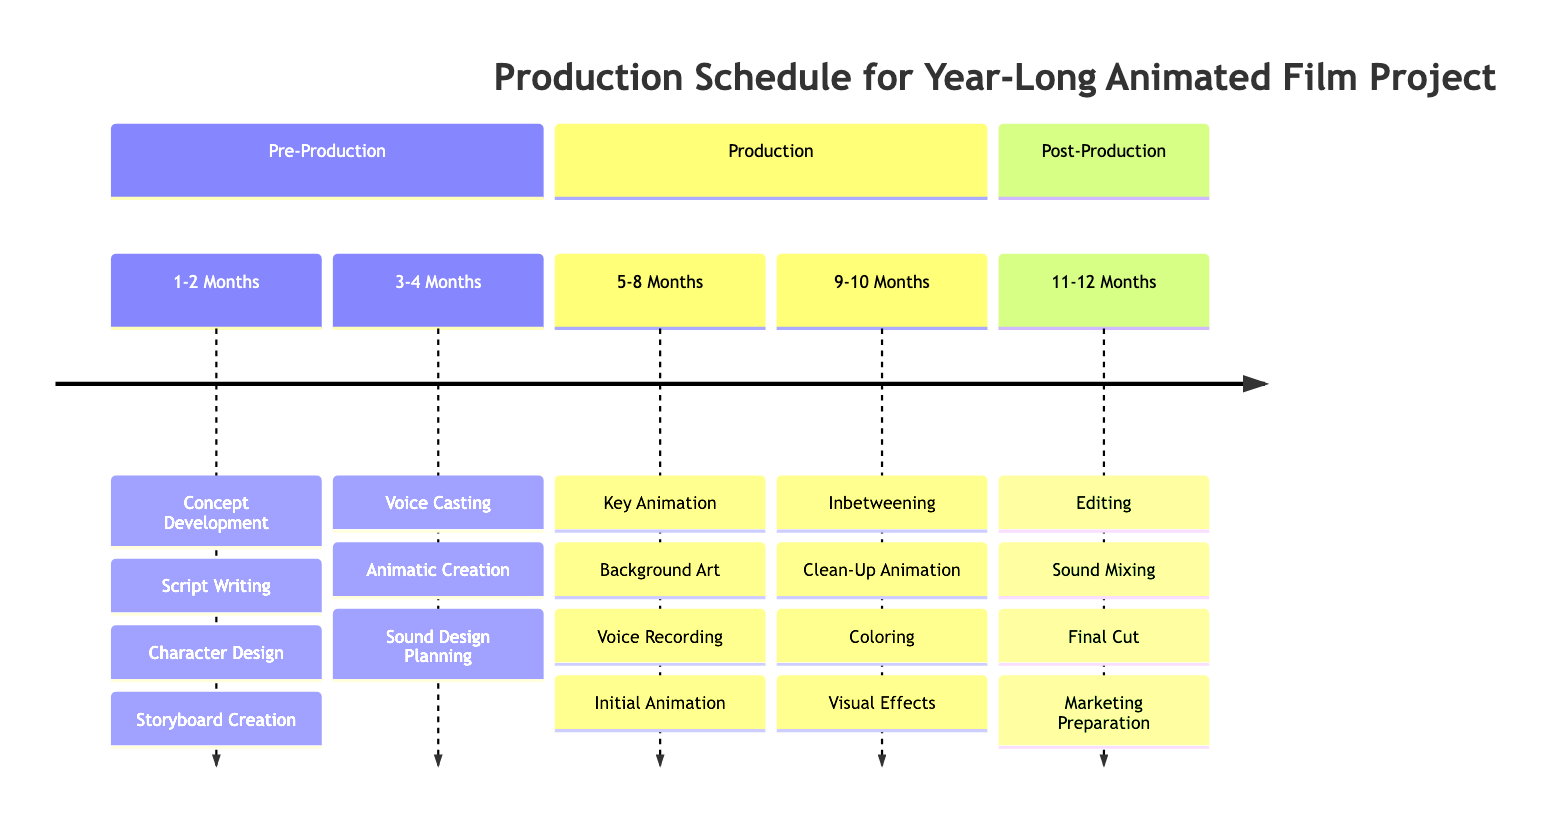What are the main phases of the production schedule? The diagram provides three primary phases: Pre-Production, Production, and Post-Production. Each phase is clearly defined in separate sections of the timeline.
Answer: Pre-Production, Production, Post-Production How long is the Pre-Production phase? The Pre-Production phase is divided into two segments: 1-2 months and 3-4 months, adding up to a total of 4 months for the entire phase.
Answer: 4 months What activities are involved in the Production phase from months 5 to 10? For months 5 to 8, the activities are Key Animation, Background Art, Voice Recording, and Initial Animation. For months 9 to 10, the activities are Inbetweening, Clean-Up Animation, Coloring, and Visual Effects. This requires looking at both segments of the Production phase.
Answer: Key Animation, Background Art, Voice Recording, Initial Animation, Inbetweening, Clean-Up Animation, Coloring, Visual Effects Which task comes immediately after Storyboard Creation? The task that follows Storyboard Creation is Voice Casting, as they are listed sequentially in the timeline.
Answer: Voice Casting How many tasks are listed under Post-Production? There are four tasks under Post-Production: Editing, Sound Mixing, Final Cut, and Marketing Preparation. This is obtained by counting the listed tasks in the Post-Production section of the timeline.
Answer: 4 tasks What is the last task in the entire production schedule? The last task listed is Marketing Preparation, which is the final task under Post-Production at the end of the timeline.
Answer: Marketing Preparation In which month does voice recording take place? Voice Recording is scheduled during the 5 to 8 months segment of the Production phase, specifically within that time frame.
Answer: 5 to 8 months What is the function of Animatic Creation in the timeline? Animatic Creation is a part of the Voice Casting and Sound Design Planning tasks in the 3-4 months segment of Pre-Production, indicating its role in preparing visual interactions for sound and narration.
Answer: Preparation for animation How is the timeline divided for the production phases? The Production phase is divided into two parts: the first spans months 5 to 8 and the second spans months 9 to 10, clearly illustrating a progression from initial animation to refinement.
Answer: Two parts: 5 to 8 months and 9 to 10 months 